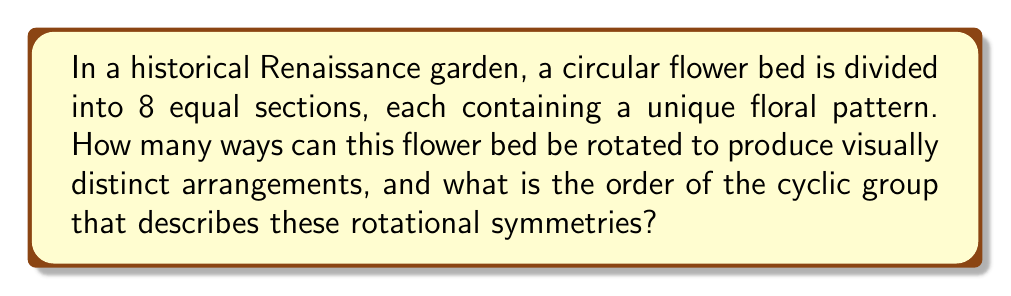Show me your answer to this math problem. Let's approach this step-by-step using group theory:

1) First, we need to understand what constitutes a distinct arrangement. In this case, a rotation that brings the flower bed back to a visually identical state is not considered distinct.

2) The flower bed has 8 equal sections. This means we can rotate it by multiples of 45° (360° / 8 = 45°) to get all possible arrangements.

3) Let's list out all possible rotations:
   - 0° (original position)
   - 45°
   - 90°
   - 135°
   - 180°
   - 225°
   - 270°
   - 315°

4) Each of these rotations produces a visually distinct arrangement because each section contains a unique pattern.

5) After a 360° rotation, we return to the original position. This forms a cycle.

6) In group theory, this type of symmetry is described by a cyclic group. The order of a cyclic group is the number of elements in the group.

7) In this case, we have 8 distinct rotations (including the identity rotation of 0°), so the order of the cyclic group is 8.

8) We can denote this group as $C_8$ or $\mathbb{Z}_8$.

Therefore, there are 8 ways to rotate the flower bed to produce visually distinct arrangements, and the order of the cyclic group describing these rotational symmetries is 8.
Answer: 8 